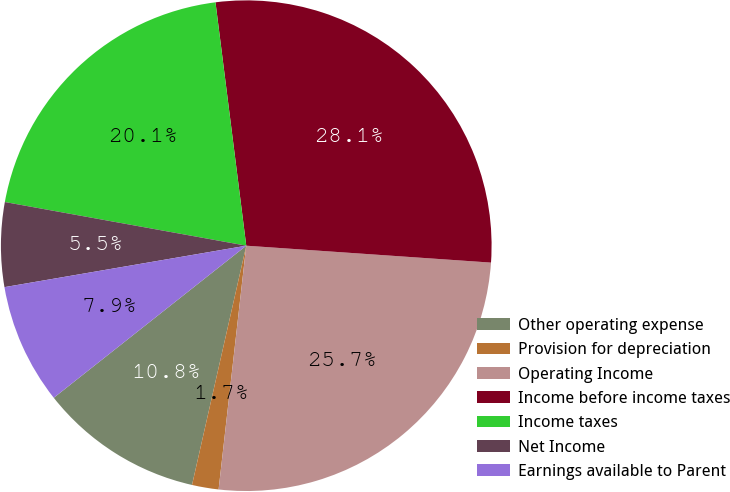<chart> <loc_0><loc_0><loc_500><loc_500><pie_chart><fcel>Other operating expense<fcel>Provision for depreciation<fcel>Operating Income<fcel>Income before income taxes<fcel>Income taxes<fcel>Net Income<fcel>Earnings available to Parent<nl><fcel>10.81%<fcel>1.75%<fcel>25.7%<fcel>28.1%<fcel>20.15%<fcel>5.55%<fcel>7.94%<nl></chart> 